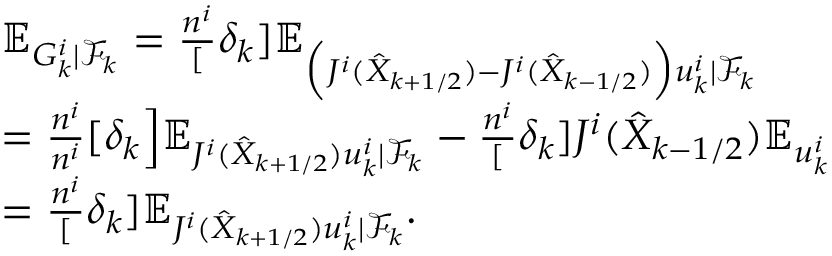Convert formula to latex. <formula><loc_0><loc_0><loc_500><loc_500>\begin{array} { r l } & { \mathbb { E } _ { G _ { k } ^ { i } | \mathcal { F } _ { k } } = \frac { n ^ { i } } [ \delta _ { k } ] \mathbb { E } _ { \Big ( J ^ { i } ( \hat { X } _ { k + 1 / 2 } ) - J ^ { i } ( \hat { X } _ { k - 1 / 2 } ) \Big ) u _ { k } ^ { i } | \mathcal { F } _ { k } } } \\ & { = \frac { n ^ { i } } { n ^ { i } } [ \delta _ { k } \Big ] \mathbb { E } _ { J ^ { i } ( \hat { X } _ { k + 1 / 2 } ) u _ { k } ^ { i } | \mathcal { F } _ { k } } - \frac { n ^ { i } } [ \delta _ { k } ] J ^ { i } ( \hat { X } _ { k - 1 / 2 } ) \mathbb { E } _ { u _ { k } ^ { i } } } \\ & { = \frac { n ^ { i } } [ \delta _ { k } ] \mathbb { E } _ { J ^ { i } ( \hat { X } _ { k + 1 / 2 } ) u _ { k } ^ { i } | \mathcal { F } _ { k } } . } \end{array}</formula> 